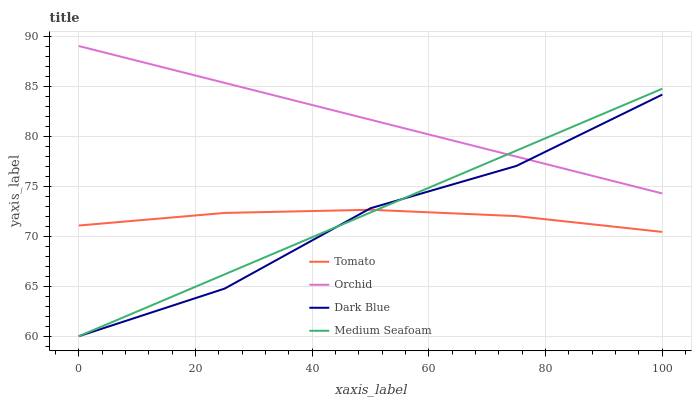Does Dark Blue have the minimum area under the curve?
Answer yes or no. Yes. Does Orchid have the maximum area under the curve?
Answer yes or no. Yes. Does Medium Seafoam have the minimum area under the curve?
Answer yes or no. No. Does Medium Seafoam have the maximum area under the curve?
Answer yes or no. No. Is Medium Seafoam the smoothest?
Answer yes or no. Yes. Is Dark Blue the roughest?
Answer yes or no. Yes. Is Dark Blue the smoothest?
Answer yes or no. No. Is Medium Seafoam the roughest?
Answer yes or no. No. Does Orchid have the lowest value?
Answer yes or no. No. Does Dark Blue have the highest value?
Answer yes or no. No. Is Tomato less than Orchid?
Answer yes or no. Yes. Is Orchid greater than Tomato?
Answer yes or no. Yes. Does Tomato intersect Orchid?
Answer yes or no. No. 